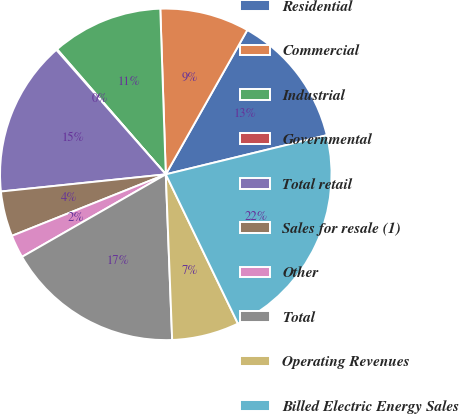Convert chart to OTSL. <chart><loc_0><loc_0><loc_500><loc_500><pie_chart><fcel>Residential<fcel>Commercial<fcel>Industrial<fcel>Governmental<fcel>Total retail<fcel>Sales for resale (1)<fcel>Other<fcel>Total<fcel>Operating Revenues<fcel>Billed Electric Energy Sales<nl><fcel>13.02%<fcel>8.71%<fcel>10.86%<fcel>0.09%<fcel>15.17%<fcel>4.4%<fcel>2.24%<fcel>17.32%<fcel>6.55%<fcel>21.63%<nl></chart> 